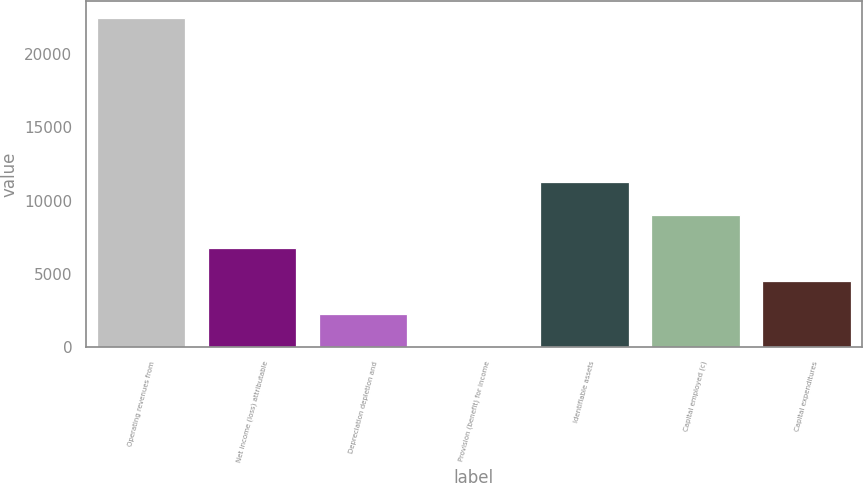<chart> <loc_0><loc_0><loc_500><loc_500><bar_chart><fcel>Operating revenues from<fcel>Net income (loss) attributable<fcel>Depreciation depletion and<fcel>Provision (benefit) for income<fcel>Identifiable assets<fcel>Capital employed (c)<fcel>Capital expenditures<nl><fcel>22464<fcel>6756<fcel>2268<fcel>24<fcel>11244<fcel>9000<fcel>4512<nl></chart> 